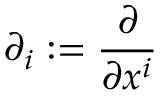<formula> <loc_0><loc_0><loc_500><loc_500>\partial _ { i } \colon = { \frac { \partial } { \partial x ^ { i } } }</formula> 